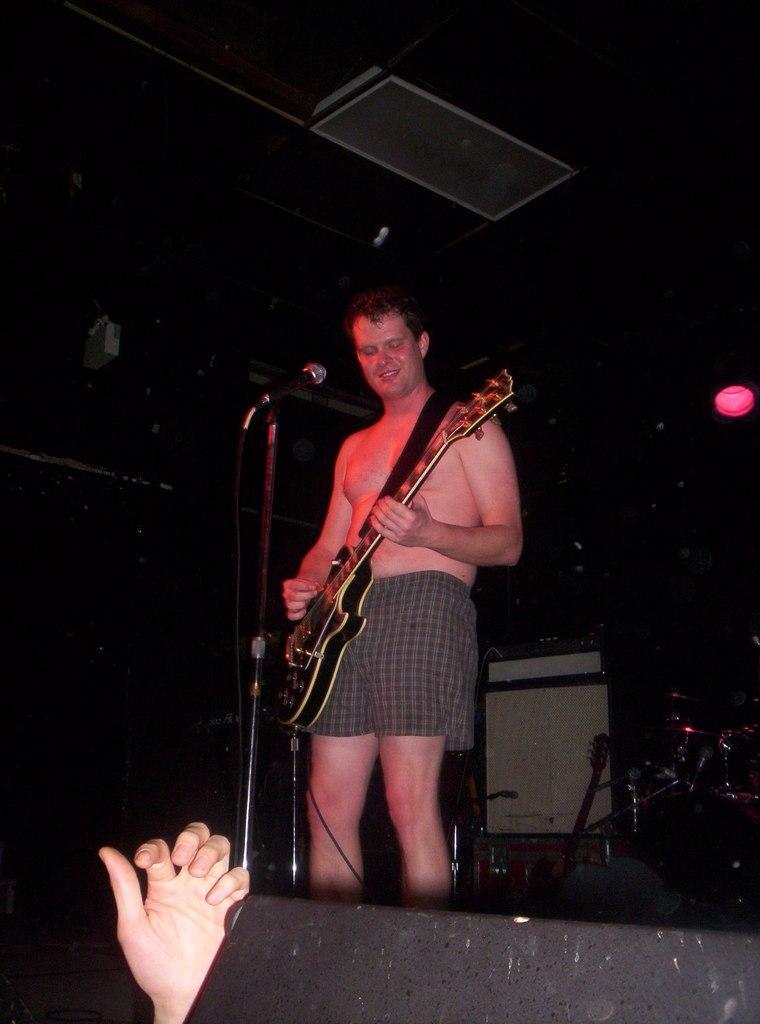Please provide a concise description of this image. In this picture we can see man holding guitar in his hand and playing it and smiling and in front of him we can see mic stand, person's hand and in background we can see light and it is dark. 